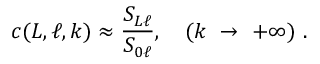Convert formula to latex. <formula><loc_0><loc_0><loc_500><loc_500>c ( L , \ell , k ) \approx \frac { S _ { L \ell } } { S _ { 0 \ell } } , ( k \rightarrow + \infty ) .</formula> 